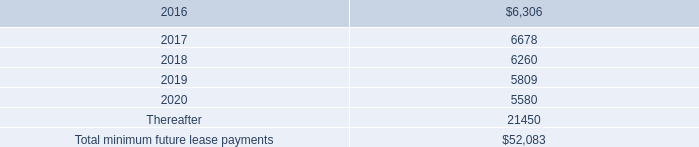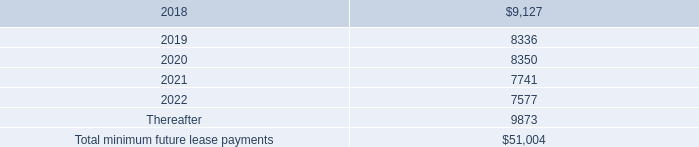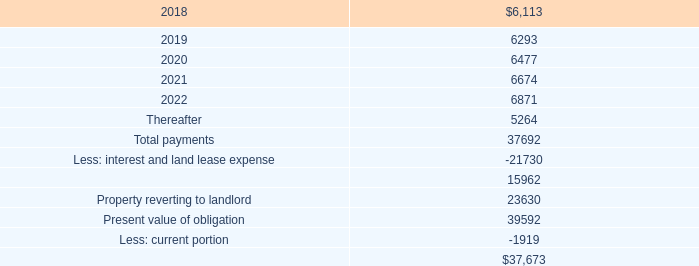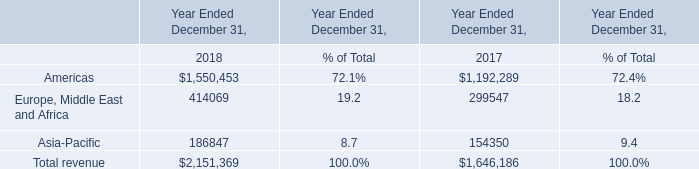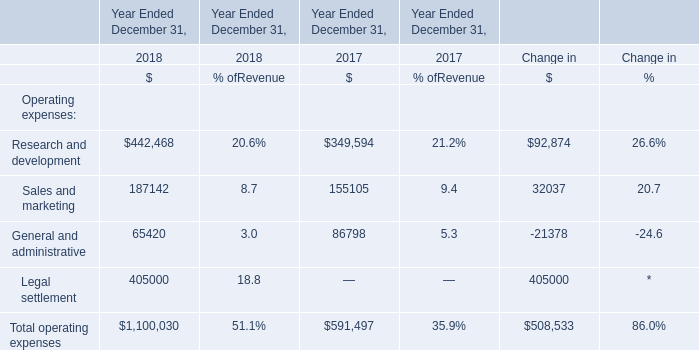what is the total rent expense for the period from december 31 , 2017 , 2016 and 2015 in millions 
Computations: ((9.4 + 8.1) + 5.4)
Answer: 22.9. 